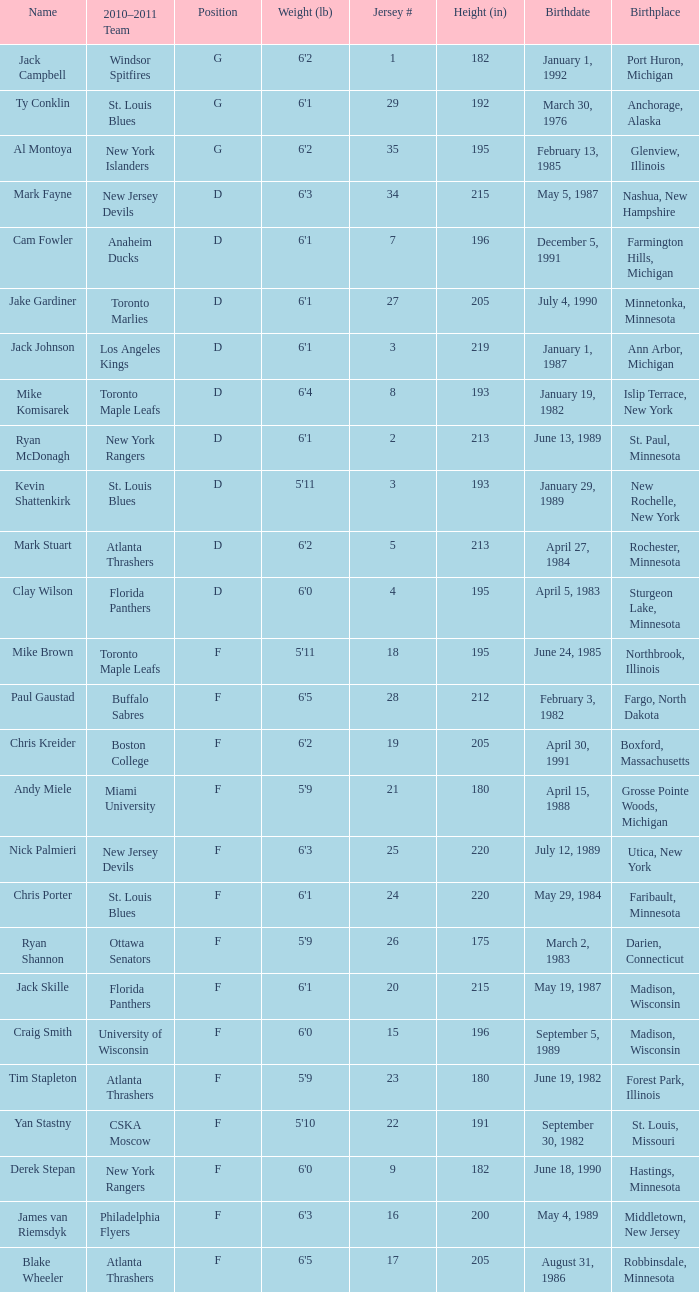Which birthplace's height in inches was more than 192 when the position was d and the birthday was April 5, 1983? Sturgeon Lake, Minnesota. 